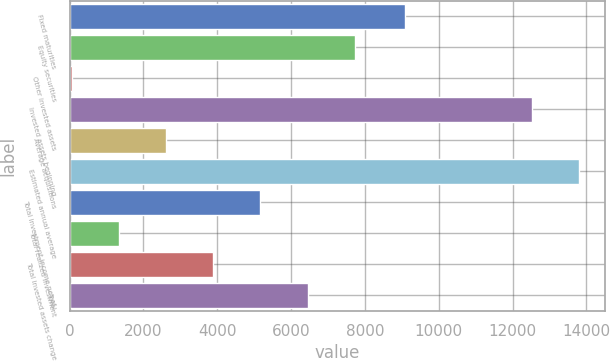<chart> <loc_0><loc_0><loc_500><loc_500><bar_chart><fcel>Fixed maturities<fcel>Equity securities<fcel>Other invested assets<fcel>Invested assets beginning<fcel>Average acquisitions<fcel>Estimated annual average<fcel>Total investment income net of<fcel>Total realized investment<fcel>Total invested assets change<fcel>Total<nl><fcel>9093<fcel>7720.4<fcel>68<fcel>12534<fcel>2618.8<fcel>13809.4<fcel>5169.6<fcel>1343.4<fcel>3894.2<fcel>6445<nl></chart> 